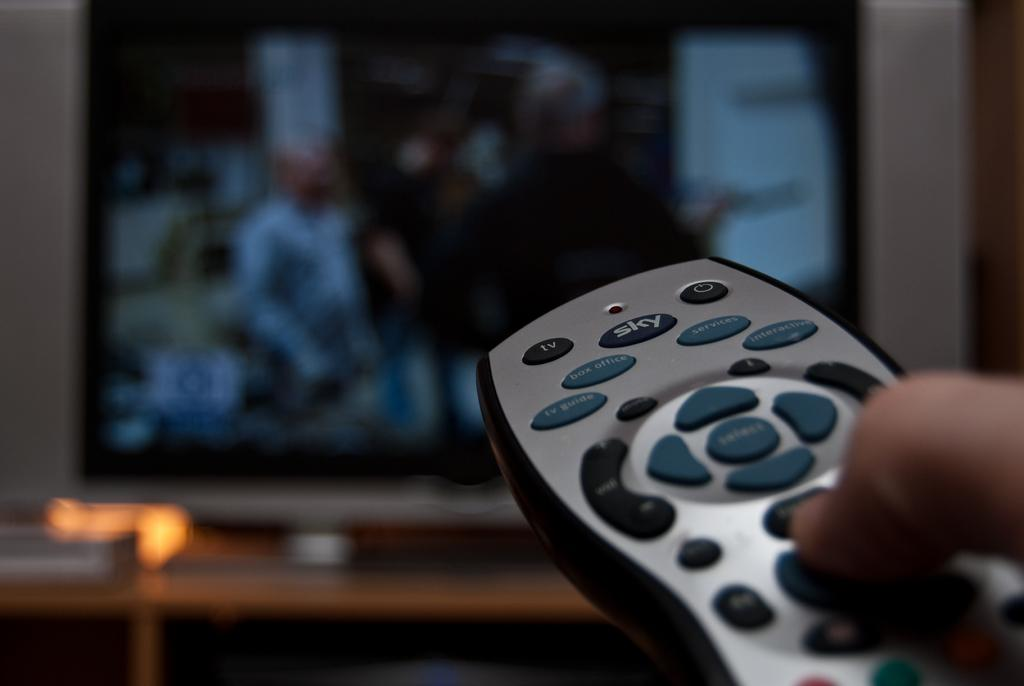Who is present in the image? There is a person in the image. What is the person doing in the image? The person is operating a remote. What device is the person likely controlling with the remote? There is a television in the image, so the person is likely controlling the television. Can you describe the describe the background of the image? The backdrop of the image is blurred. What type of monkey can be seen eating lunch in the image? There is no monkey or lunch present in the image. What kind of fowl is visible in the image? There is no fowl visible in the image. 